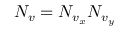Convert formula to latex. <formula><loc_0><loc_0><loc_500><loc_500>N _ { v } = N _ { v _ { x } } N _ { v _ { y } }</formula> 